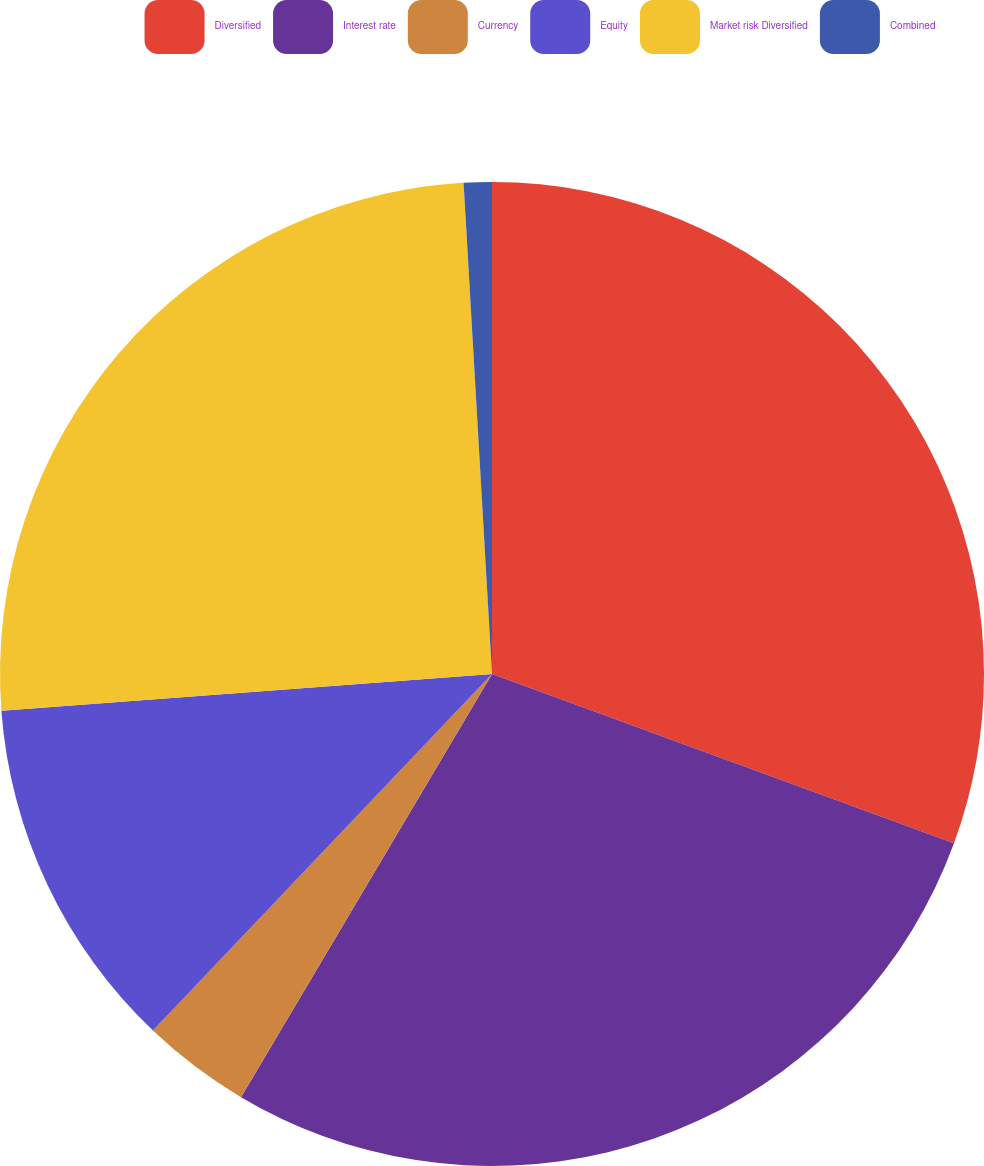<chart> <loc_0><loc_0><loc_500><loc_500><pie_chart><fcel>Diversified<fcel>Interest rate<fcel>Currency<fcel>Equity<fcel>Market risk Diversified<fcel>Combined<nl><fcel>30.59%<fcel>27.93%<fcel>3.58%<fcel>11.71%<fcel>25.27%<fcel>0.92%<nl></chart> 